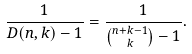<formula> <loc_0><loc_0><loc_500><loc_500>\frac { 1 } { D ( n , k ) - 1 } = \frac { 1 } { \binom { n + k - 1 } { k } - 1 } .</formula> 